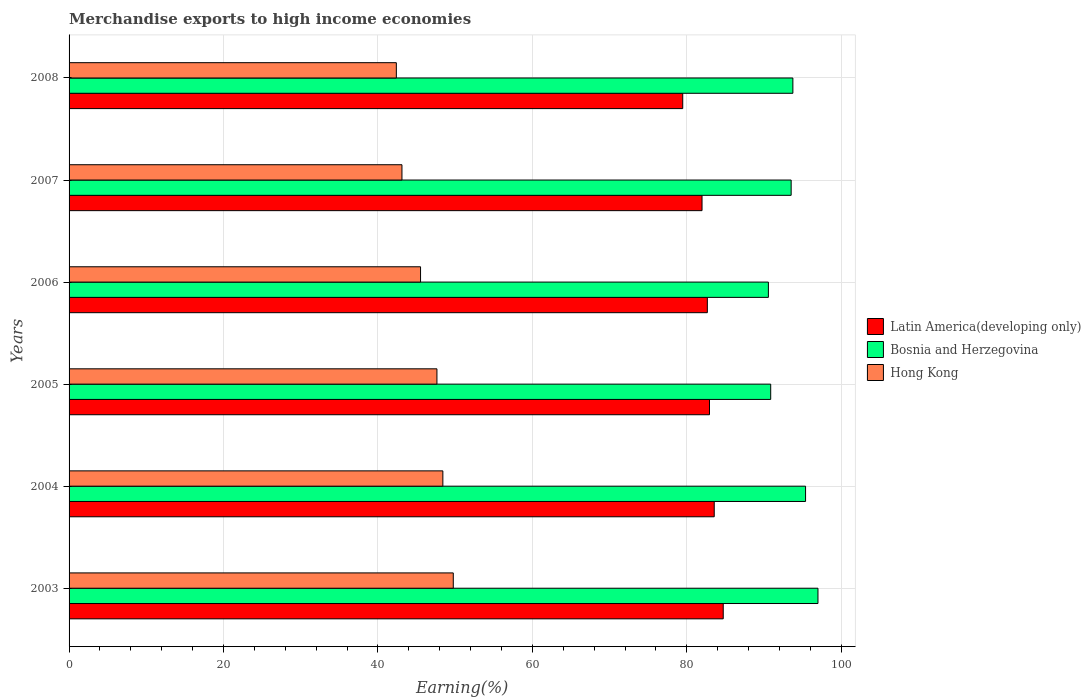How many different coloured bars are there?
Ensure brevity in your answer.  3. Are the number of bars on each tick of the Y-axis equal?
Offer a very short reply. Yes. What is the label of the 3rd group of bars from the top?
Keep it short and to the point. 2006. In how many cases, is the number of bars for a given year not equal to the number of legend labels?
Provide a succinct answer. 0. What is the percentage of amount earned from merchandise exports in Hong Kong in 2004?
Offer a terse response. 48.41. Across all years, what is the maximum percentage of amount earned from merchandise exports in Hong Kong?
Your answer should be compact. 49.76. Across all years, what is the minimum percentage of amount earned from merchandise exports in Latin America(developing only)?
Offer a terse response. 79.48. What is the total percentage of amount earned from merchandise exports in Latin America(developing only) in the graph?
Provide a short and direct response. 495.34. What is the difference between the percentage of amount earned from merchandise exports in Bosnia and Herzegovina in 2004 and that in 2008?
Your answer should be very brief. 1.64. What is the difference between the percentage of amount earned from merchandise exports in Bosnia and Herzegovina in 2006 and the percentage of amount earned from merchandise exports in Latin America(developing only) in 2008?
Ensure brevity in your answer.  11.09. What is the average percentage of amount earned from merchandise exports in Hong Kong per year?
Offer a very short reply. 46.14. In the year 2003, what is the difference between the percentage of amount earned from merchandise exports in Hong Kong and percentage of amount earned from merchandise exports in Latin America(developing only)?
Provide a short and direct response. -34.96. What is the ratio of the percentage of amount earned from merchandise exports in Bosnia and Herzegovina in 2004 to that in 2005?
Offer a very short reply. 1.05. Is the percentage of amount earned from merchandise exports in Bosnia and Herzegovina in 2005 less than that in 2006?
Make the answer very short. No. Is the difference between the percentage of amount earned from merchandise exports in Hong Kong in 2004 and 2006 greater than the difference between the percentage of amount earned from merchandise exports in Latin America(developing only) in 2004 and 2006?
Give a very brief answer. Yes. What is the difference between the highest and the second highest percentage of amount earned from merchandise exports in Bosnia and Herzegovina?
Your answer should be very brief. 1.61. What is the difference between the highest and the lowest percentage of amount earned from merchandise exports in Hong Kong?
Your answer should be compact. 7.37. Is the sum of the percentage of amount earned from merchandise exports in Latin America(developing only) in 2003 and 2008 greater than the maximum percentage of amount earned from merchandise exports in Hong Kong across all years?
Keep it short and to the point. Yes. What does the 2nd bar from the top in 2006 represents?
Your answer should be compact. Bosnia and Herzegovina. What does the 1st bar from the bottom in 2008 represents?
Offer a terse response. Latin America(developing only). How many bars are there?
Offer a very short reply. 18. Are all the bars in the graph horizontal?
Your response must be concise. Yes. How many years are there in the graph?
Ensure brevity in your answer.  6. Are the values on the major ticks of X-axis written in scientific E-notation?
Offer a very short reply. No. What is the title of the graph?
Your answer should be very brief. Merchandise exports to high income economies. Does "Sao Tome and Principe" appear as one of the legend labels in the graph?
Give a very brief answer. No. What is the label or title of the X-axis?
Your answer should be very brief. Earning(%). What is the Earning(%) of Latin America(developing only) in 2003?
Give a very brief answer. 84.72. What is the Earning(%) of Bosnia and Herzegovina in 2003?
Ensure brevity in your answer.  96.99. What is the Earning(%) in Hong Kong in 2003?
Offer a very short reply. 49.76. What is the Earning(%) of Latin America(developing only) in 2004?
Offer a very short reply. 83.56. What is the Earning(%) of Bosnia and Herzegovina in 2004?
Your response must be concise. 95.39. What is the Earning(%) in Hong Kong in 2004?
Offer a terse response. 48.41. What is the Earning(%) of Latin America(developing only) in 2005?
Ensure brevity in your answer.  82.94. What is the Earning(%) in Bosnia and Herzegovina in 2005?
Give a very brief answer. 90.87. What is the Earning(%) in Hong Kong in 2005?
Make the answer very short. 47.64. What is the Earning(%) of Latin America(developing only) in 2006?
Ensure brevity in your answer.  82.66. What is the Earning(%) of Bosnia and Herzegovina in 2006?
Provide a short and direct response. 90.57. What is the Earning(%) in Hong Kong in 2006?
Keep it short and to the point. 45.52. What is the Earning(%) in Latin America(developing only) in 2007?
Give a very brief answer. 81.98. What is the Earning(%) of Bosnia and Herzegovina in 2007?
Your response must be concise. 93.52. What is the Earning(%) of Hong Kong in 2007?
Ensure brevity in your answer.  43.11. What is the Earning(%) in Latin America(developing only) in 2008?
Ensure brevity in your answer.  79.48. What is the Earning(%) of Bosnia and Herzegovina in 2008?
Make the answer very short. 93.74. What is the Earning(%) of Hong Kong in 2008?
Provide a short and direct response. 42.39. Across all years, what is the maximum Earning(%) of Latin America(developing only)?
Give a very brief answer. 84.72. Across all years, what is the maximum Earning(%) of Bosnia and Herzegovina?
Provide a short and direct response. 96.99. Across all years, what is the maximum Earning(%) of Hong Kong?
Your response must be concise. 49.76. Across all years, what is the minimum Earning(%) in Latin America(developing only)?
Offer a terse response. 79.48. Across all years, what is the minimum Earning(%) of Bosnia and Herzegovina?
Offer a very short reply. 90.57. Across all years, what is the minimum Earning(%) of Hong Kong?
Your answer should be very brief. 42.39. What is the total Earning(%) in Latin America(developing only) in the graph?
Your response must be concise. 495.34. What is the total Earning(%) of Bosnia and Herzegovina in the graph?
Offer a very short reply. 561.08. What is the total Earning(%) in Hong Kong in the graph?
Ensure brevity in your answer.  276.83. What is the difference between the Earning(%) of Latin America(developing only) in 2003 and that in 2004?
Ensure brevity in your answer.  1.17. What is the difference between the Earning(%) of Bosnia and Herzegovina in 2003 and that in 2004?
Offer a very short reply. 1.61. What is the difference between the Earning(%) of Hong Kong in 2003 and that in 2004?
Make the answer very short. 1.35. What is the difference between the Earning(%) of Latin America(developing only) in 2003 and that in 2005?
Keep it short and to the point. 1.78. What is the difference between the Earning(%) in Bosnia and Herzegovina in 2003 and that in 2005?
Your answer should be very brief. 6.12. What is the difference between the Earning(%) of Hong Kong in 2003 and that in 2005?
Give a very brief answer. 2.12. What is the difference between the Earning(%) in Latin America(developing only) in 2003 and that in 2006?
Offer a very short reply. 2.06. What is the difference between the Earning(%) in Bosnia and Herzegovina in 2003 and that in 2006?
Keep it short and to the point. 6.42. What is the difference between the Earning(%) in Hong Kong in 2003 and that in 2006?
Give a very brief answer. 4.24. What is the difference between the Earning(%) of Latin America(developing only) in 2003 and that in 2007?
Provide a short and direct response. 2.75. What is the difference between the Earning(%) in Bosnia and Herzegovina in 2003 and that in 2007?
Provide a succinct answer. 3.47. What is the difference between the Earning(%) of Hong Kong in 2003 and that in 2007?
Give a very brief answer. 6.65. What is the difference between the Earning(%) in Latin America(developing only) in 2003 and that in 2008?
Offer a terse response. 5.25. What is the difference between the Earning(%) of Bosnia and Herzegovina in 2003 and that in 2008?
Your answer should be compact. 3.25. What is the difference between the Earning(%) in Hong Kong in 2003 and that in 2008?
Make the answer very short. 7.37. What is the difference between the Earning(%) of Latin America(developing only) in 2004 and that in 2005?
Provide a short and direct response. 0.61. What is the difference between the Earning(%) of Bosnia and Herzegovina in 2004 and that in 2005?
Make the answer very short. 4.52. What is the difference between the Earning(%) in Hong Kong in 2004 and that in 2005?
Offer a very short reply. 0.77. What is the difference between the Earning(%) of Latin America(developing only) in 2004 and that in 2006?
Your answer should be compact. 0.89. What is the difference between the Earning(%) in Bosnia and Herzegovina in 2004 and that in 2006?
Ensure brevity in your answer.  4.81. What is the difference between the Earning(%) of Hong Kong in 2004 and that in 2006?
Keep it short and to the point. 2.89. What is the difference between the Earning(%) in Latin America(developing only) in 2004 and that in 2007?
Offer a terse response. 1.58. What is the difference between the Earning(%) in Bosnia and Herzegovina in 2004 and that in 2007?
Ensure brevity in your answer.  1.87. What is the difference between the Earning(%) of Hong Kong in 2004 and that in 2007?
Provide a short and direct response. 5.3. What is the difference between the Earning(%) of Latin America(developing only) in 2004 and that in 2008?
Ensure brevity in your answer.  4.08. What is the difference between the Earning(%) of Bosnia and Herzegovina in 2004 and that in 2008?
Your answer should be compact. 1.64. What is the difference between the Earning(%) of Hong Kong in 2004 and that in 2008?
Give a very brief answer. 6.02. What is the difference between the Earning(%) in Latin America(developing only) in 2005 and that in 2006?
Keep it short and to the point. 0.28. What is the difference between the Earning(%) of Bosnia and Herzegovina in 2005 and that in 2006?
Your answer should be very brief. 0.3. What is the difference between the Earning(%) of Hong Kong in 2005 and that in 2006?
Make the answer very short. 2.12. What is the difference between the Earning(%) of Latin America(developing only) in 2005 and that in 2007?
Offer a very short reply. 0.97. What is the difference between the Earning(%) of Bosnia and Herzegovina in 2005 and that in 2007?
Provide a short and direct response. -2.65. What is the difference between the Earning(%) in Hong Kong in 2005 and that in 2007?
Give a very brief answer. 4.53. What is the difference between the Earning(%) in Latin America(developing only) in 2005 and that in 2008?
Keep it short and to the point. 3.47. What is the difference between the Earning(%) of Bosnia and Herzegovina in 2005 and that in 2008?
Your answer should be very brief. -2.87. What is the difference between the Earning(%) in Hong Kong in 2005 and that in 2008?
Offer a terse response. 5.26. What is the difference between the Earning(%) of Latin America(developing only) in 2006 and that in 2007?
Your answer should be compact. 0.69. What is the difference between the Earning(%) in Bosnia and Herzegovina in 2006 and that in 2007?
Offer a terse response. -2.95. What is the difference between the Earning(%) in Hong Kong in 2006 and that in 2007?
Offer a very short reply. 2.41. What is the difference between the Earning(%) of Latin America(developing only) in 2006 and that in 2008?
Make the answer very short. 3.19. What is the difference between the Earning(%) in Bosnia and Herzegovina in 2006 and that in 2008?
Your answer should be very brief. -3.17. What is the difference between the Earning(%) of Hong Kong in 2006 and that in 2008?
Make the answer very short. 3.13. What is the difference between the Earning(%) of Latin America(developing only) in 2007 and that in 2008?
Provide a succinct answer. 2.5. What is the difference between the Earning(%) in Bosnia and Herzegovina in 2007 and that in 2008?
Make the answer very short. -0.22. What is the difference between the Earning(%) in Hong Kong in 2007 and that in 2008?
Keep it short and to the point. 0.73. What is the difference between the Earning(%) in Latin America(developing only) in 2003 and the Earning(%) in Bosnia and Herzegovina in 2004?
Give a very brief answer. -10.66. What is the difference between the Earning(%) in Latin America(developing only) in 2003 and the Earning(%) in Hong Kong in 2004?
Give a very brief answer. 36.31. What is the difference between the Earning(%) of Bosnia and Herzegovina in 2003 and the Earning(%) of Hong Kong in 2004?
Your answer should be very brief. 48.58. What is the difference between the Earning(%) in Latin America(developing only) in 2003 and the Earning(%) in Bosnia and Herzegovina in 2005?
Offer a terse response. -6.15. What is the difference between the Earning(%) of Latin America(developing only) in 2003 and the Earning(%) of Hong Kong in 2005?
Give a very brief answer. 37.08. What is the difference between the Earning(%) of Bosnia and Herzegovina in 2003 and the Earning(%) of Hong Kong in 2005?
Ensure brevity in your answer.  49.35. What is the difference between the Earning(%) of Latin America(developing only) in 2003 and the Earning(%) of Bosnia and Herzegovina in 2006?
Your answer should be compact. -5.85. What is the difference between the Earning(%) of Latin America(developing only) in 2003 and the Earning(%) of Hong Kong in 2006?
Your answer should be compact. 39.2. What is the difference between the Earning(%) of Bosnia and Herzegovina in 2003 and the Earning(%) of Hong Kong in 2006?
Offer a very short reply. 51.47. What is the difference between the Earning(%) of Latin America(developing only) in 2003 and the Earning(%) of Bosnia and Herzegovina in 2007?
Your answer should be compact. -8.8. What is the difference between the Earning(%) in Latin America(developing only) in 2003 and the Earning(%) in Hong Kong in 2007?
Give a very brief answer. 41.61. What is the difference between the Earning(%) in Bosnia and Herzegovina in 2003 and the Earning(%) in Hong Kong in 2007?
Provide a succinct answer. 53.88. What is the difference between the Earning(%) of Latin America(developing only) in 2003 and the Earning(%) of Bosnia and Herzegovina in 2008?
Your answer should be very brief. -9.02. What is the difference between the Earning(%) of Latin America(developing only) in 2003 and the Earning(%) of Hong Kong in 2008?
Offer a very short reply. 42.34. What is the difference between the Earning(%) of Bosnia and Herzegovina in 2003 and the Earning(%) of Hong Kong in 2008?
Keep it short and to the point. 54.61. What is the difference between the Earning(%) of Latin America(developing only) in 2004 and the Earning(%) of Bosnia and Herzegovina in 2005?
Provide a short and direct response. -7.31. What is the difference between the Earning(%) in Latin America(developing only) in 2004 and the Earning(%) in Hong Kong in 2005?
Provide a succinct answer. 35.91. What is the difference between the Earning(%) of Bosnia and Herzegovina in 2004 and the Earning(%) of Hong Kong in 2005?
Provide a succinct answer. 47.74. What is the difference between the Earning(%) in Latin America(developing only) in 2004 and the Earning(%) in Bosnia and Herzegovina in 2006?
Keep it short and to the point. -7.01. What is the difference between the Earning(%) of Latin America(developing only) in 2004 and the Earning(%) of Hong Kong in 2006?
Ensure brevity in your answer.  38.04. What is the difference between the Earning(%) in Bosnia and Herzegovina in 2004 and the Earning(%) in Hong Kong in 2006?
Your answer should be compact. 49.87. What is the difference between the Earning(%) in Latin America(developing only) in 2004 and the Earning(%) in Bosnia and Herzegovina in 2007?
Keep it short and to the point. -9.96. What is the difference between the Earning(%) in Latin America(developing only) in 2004 and the Earning(%) in Hong Kong in 2007?
Offer a very short reply. 40.44. What is the difference between the Earning(%) in Bosnia and Herzegovina in 2004 and the Earning(%) in Hong Kong in 2007?
Offer a terse response. 52.27. What is the difference between the Earning(%) in Latin America(developing only) in 2004 and the Earning(%) in Bosnia and Herzegovina in 2008?
Offer a very short reply. -10.19. What is the difference between the Earning(%) in Latin America(developing only) in 2004 and the Earning(%) in Hong Kong in 2008?
Your response must be concise. 41.17. What is the difference between the Earning(%) in Bosnia and Herzegovina in 2004 and the Earning(%) in Hong Kong in 2008?
Keep it short and to the point. 53. What is the difference between the Earning(%) in Latin America(developing only) in 2005 and the Earning(%) in Bosnia and Herzegovina in 2006?
Provide a succinct answer. -7.63. What is the difference between the Earning(%) in Latin America(developing only) in 2005 and the Earning(%) in Hong Kong in 2006?
Your answer should be very brief. 37.42. What is the difference between the Earning(%) in Bosnia and Herzegovina in 2005 and the Earning(%) in Hong Kong in 2006?
Ensure brevity in your answer.  45.35. What is the difference between the Earning(%) in Latin America(developing only) in 2005 and the Earning(%) in Bosnia and Herzegovina in 2007?
Make the answer very short. -10.57. What is the difference between the Earning(%) in Latin America(developing only) in 2005 and the Earning(%) in Hong Kong in 2007?
Offer a terse response. 39.83. What is the difference between the Earning(%) of Bosnia and Herzegovina in 2005 and the Earning(%) of Hong Kong in 2007?
Make the answer very short. 47.76. What is the difference between the Earning(%) of Latin America(developing only) in 2005 and the Earning(%) of Bosnia and Herzegovina in 2008?
Make the answer very short. -10.8. What is the difference between the Earning(%) of Latin America(developing only) in 2005 and the Earning(%) of Hong Kong in 2008?
Your response must be concise. 40.56. What is the difference between the Earning(%) in Bosnia and Herzegovina in 2005 and the Earning(%) in Hong Kong in 2008?
Keep it short and to the point. 48.48. What is the difference between the Earning(%) of Latin America(developing only) in 2006 and the Earning(%) of Bosnia and Herzegovina in 2007?
Give a very brief answer. -10.85. What is the difference between the Earning(%) of Latin America(developing only) in 2006 and the Earning(%) of Hong Kong in 2007?
Provide a succinct answer. 39.55. What is the difference between the Earning(%) in Bosnia and Herzegovina in 2006 and the Earning(%) in Hong Kong in 2007?
Offer a very short reply. 47.46. What is the difference between the Earning(%) of Latin America(developing only) in 2006 and the Earning(%) of Bosnia and Herzegovina in 2008?
Your response must be concise. -11.08. What is the difference between the Earning(%) in Latin America(developing only) in 2006 and the Earning(%) in Hong Kong in 2008?
Offer a terse response. 40.28. What is the difference between the Earning(%) of Bosnia and Herzegovina in 2006 and the Earning(%) of Hong Kong in 2008?
Give a very brief answer. 48.18. What is the difference between the Earning(%) of Latin America(developing only) in 2007 and the Earning(%) of Bosnia and Herzegovina in 2008?
Provide a succinct answer. -11.77. What is the difference between the Earning(%) in Latin America(developing only) in 2007 and the Earning(%) in Hong Kong in 2008?
Your answer should be very brief. 39.59. What is the difference between the Earning(%) of Bosnia and Herzegovina in 2007 and the Earning(%) of Hong Kong in 2008?
Your answer should be very brief. 51.13. What is the average Earning(%) of Latin America(developing only) per year?
Your answer should be very brief. 82.56. What is the average Earning(%) of Bosnia and Herzegovina per year?
Offer a terse response. 93.51. What is the average Earning(%) of Hong Kong per year?
Your answer should be compact. 46.14. In the year 2003, what is the difference between the Earning(%) of Latin America(developing only) and Earning(%) of Bosnia and Herzegovina?
Keep it short and to the point. -12.27. In the year 2003, what is the difference between the Earning(%) in Latin America(developing only) and Earning(%) in Hong Kong?
Ensure brevity in your answer.  34.96. In the year 2003, what is the difference between the Earning(%) of Bosnia and Herzegovina and Earning(%) of Hong Kong?
Keep it short and to the point. 47.23. In the year 2004, what is the difference between the Earning(%) in Latin America(developing only) and Earning(%) in Bosnia and Herzegovina?
Your answer should be compact. -11.83. In the year 2004, what is the difference between the Earning(%) of Latin America(developing only) and Earning(%) of Hong Kong?
Your answer should be compact. 35.15. In the year 2004, what is the difference between the Earning(%) of Bosnia and Herzegovina and Earning(%) of Hong Kong?
Make the answer very short. 46.98. In the year 2005, what is the difference between the Earning(%) in Latin America(developing only) and Earning(%) in Bosnia and Herzegovina?
Ensure brevity in your answer.  -7.93. In the year 2005, what is the difference between the Earning(%) of Latin America(developing only) and Earning(%) of Hong Kong?
Offer a very short reply. 35.3. In the year 2005, what is the difference between the Earning(%) in Bosnia and Herzegovina and Earning(%) in Hong Kong?
Give a very brief answer. 43.23. In the year 2006, what is the difference between the Earning(%) in Latin America(developing only) and Earning(%) in Bosnia and Herzegovina?
Offer a very short reply. -7.91. In the year 2006, what is the difference between the Earning(%) of Latin America(developing only) and Earning(%) of Hong Kong?
Give a very brief answer. 37.14. In the year 2006, what is the difference between the Earning(%) of Bosnia and Herzegovina and Earning(%) of Hong Kong?
Give a very brief answer. 45.05. In the year 2007, what is the difference between the Earning(%) in Latin America(developing only) and Earning(%) in Bosnia and Herzegovina?
Make the answer very short. -11.54. In the year 2007, what is the difference between the Earning(%) in Latin America(developing only) and Earning(%) in Hong Kong?
Offer a very short reply. 38.86. In the year 2007, what is the difference between the Earning(%) in Bosnia and Herzegovina and Earning(%) in Hong Kong?
Keep it short and to the point. 50.41. In the year 2008, what is the difference between the Earning(%) in Latin America(developing only) and Earning(%) in Bosnia and Herzegovina?
Make the answer very short. -14.27. In the year 2008, what is the difference between the Earning(%) of Latin America(developing only) and Earning(%) of Hong Kong?
Your answer should be very brief. 37.09. In the year 2008, what is the difference between the Earning(%) in Bosnia and Herzegovina and Earning(%) in Hong Kong?
Your response must be concise. 51.36. What is the ratio of the Earning(%) of Latin America(developing only) in 2003 to that in 2004?
Ensure brevity in your answer.  1.01. What is the ratio of the Earning(%) of Bosnia and Herzegovina in 2003 to that in 2004?
Make the answer very short. 1.02. What is the ratio of the Earning(%) of Hong Kong in 2003 to that in 2004?
Your answer should be compact. 1.03. What is the ratio of the Earning(%) in Latin America(developing only) in 2003 to that in 2005?
Ensure brevity in your answer.  1.02. What is the ratio of the Earning(%) in Bosnia and Herzegovina in 2003 to that in 2005?
Offer a very short reply. 1.07. What is the ratio of the Earning(%) of Hong Kong in 2003 to that in 2005?
Keep it short and to the point. 1.04. What is the ratio of the Earning(%) in Latin America(developing only) in 2003 to that in 2006?
Your answer should be very brief. 1.02. What is the ratio of the Earning(%) of Bosnia and Herzegovina in 2003 to that in 2006?
Give a very brief answer. 1.07. What is the ratio of the Earning(%) in Hong Kong in 2003 to that in 2006?
Ensure brevity in your answer.  1.09. What is the ratio of the Earning(%) of Latin America(developing only) in 2003 to that in 2007?
Your response must be concise. 1.03. What is the ratio of the Earning(%) of Bosnia and Herzegovina in 2003 to that in 2007?
Make the answer very short. 1.04. What is the ratio of the Earning(%) of Hong Kong in 2003 to that in 2007?
Provide a succinct answer. 1.15. What is the ratio of the Earning(%) in Latin America(developing only) in 2003 to that in 2008?
Provide a succinct answer. 1.07. What is the ratio of the Earning(%) in Bosnia and Herzegovina in 2003 to that in 2008?
Ensure brevity in your answer.  1.03. What is the ratio of the Earning(%) of Hong Kong in 2003 to that in 2008?
Ensure brevity in your answer.  1.17. What is the ratio of the Earning(%) in Latin America(developing only) in 2004 to that in 2005?
Offer a terse response. 1.01. What is the ratio of the Earning(%) of Bosnia and Herzegovina in 2004 to that in 2005?
Offer a very short reply. 1.05. What is the ratio of the Earning(%) of Hong Kong in 2004 to that in 2005?
Your answer should be compact. 1.02. What is the ratio of the Earning(%) in Latin America(developing only) in 2004 to that in 2006?
Your answer should be very brief. 1.01. What is the ratio of the Earning(%) in Bosnia and Herzegovina in 2004 to that in 2006?
Make the answer very short. 1.05. What is the ratio of the Earning(%) in Hong Kong in 2004 to that in 2006?
Ensure brevity in your answer.  1.06. What is the ratio of the Earning(%) of Latin America(developing only) in 2004 to that in 2007?
Provide a succinct answer. 1.02. What is the ratio of the Earning(%) in Bosnia and Herzegovina in 2004 to that in 2007?
Ensure brevity in your answer.  1.02. What is the ratio of the Earning(%) in Hong Kong in 2004 to that in 2007?
Your answer should be very brief. 1.12. What is the ratio of the Earning(%) of Latin America(developing only) in 2004 to that in 2008?
Ensure brevity in your answer.  1.05. What is the ratio of the Earning(%) of Bosnia and Herzegovina in 2004 to that in 2008?
Keep it short and to the point. 1.02. What is the ratio of the Earning(%) in Hong Kong in 2004 to that in 2008?
Make the answer very short. 1.14. What is the ratio of the Earning(%) of Latin America(developing only) in 2005 to that in 2006?
Offer a very short reply. 1. What is the ratio of the Earning(%) in Hong Kong in 2005 to that in 2006?
Offer a very short reply. 1.05. What is the ratio of the Earning(%) of Latin America(developing only) in 2005 to that in 2007?
Offer a terse response. 1.01. What is the ratio of the Earning(%) in Bosnia and Herzegovina in 2005 to that in 2007?
Your answer should be very brief. 0.97. What is the ratio of the Earning(%) in Hong Kong in 2005 to that in 2007?
Provide a succinct answer. 1.11. What is the ratio of the Earning(%) of Latin America(developing only) in 2005 to that in 2008?
Give a very brief answer. 1.04. What is the ratio of the Earning(%) in Bosnia and Herzegovina in 2005 to that in 2008?
Ensure brevity in your answer.  0.97. What is the ratio of the Earning(%) in Hong Kong in 2005 to that in 2008?
Give a very brief answer. 1.12. What is the ratio of the Earning(%) of Latin America(developing only) in 2006 to that in 2007?
Provide a short and direct response. 1.01. What is the ratio of the Earning(%) of Bosnia and Herzegovina in 2006 to that in 2007?
Make the answer very short. 0.97. What is the ratio of the Earning(%) of Hong Kong in 2006 to that in 2007?
Give a very brief answer. 1.06. What is the ratio of the Earning(%) of Latin America(developing only) in 2006 to that in 2008?
Your response must be concise. 1.04. What is the ratio of the Earning(%) of Bosnia and Herzegovina in 2006 to that in 2008?
Ensure brevity in your answer.  0.97. What is the ratio of the Earning(%) in Hong Kong in 2006 to that in 2008?
Keep it short and to the point. 1.07. What is the ratio of the Earning(%) of Latin America(developing only) in 2007 to that in 2008?
Keep it short and to the point. 1.03. What is the ratio of the Earning(%) of Bosnia and Herzegovina in 2007 to that in 2008?
Provide a succinct answer. 1. What is the ratio of the Earning(%) in Hong Kong in 2007 to that in 2008?
Your answer should be very brief. 1.02. What is the difference between the highest and the second highest Earning(%) of Latin America(developing only)?
Give a very brief answer. 1.17. What is the difference between the highest and the second highest Earning(%) of Bosnia and Herzegovina?
Keep it short and to the point. 1.61. What is the difference between the highest and the second highest Earning(%) of Hong Kong?
Offer a very short reply. 1.35. What is the difference between the highest and the lowest Earning(%) in Latin America(developing only)?
Offer a very short reply. 5.25. What is the difference between the highest and the lowest Earning(%) in Bosnia and Herzegovina?
Your response must be concise. 6.42. What is the difference between the highest and the lowest Earning(%) of Hong Kong?
Provide a short and direct response. 7.37. 